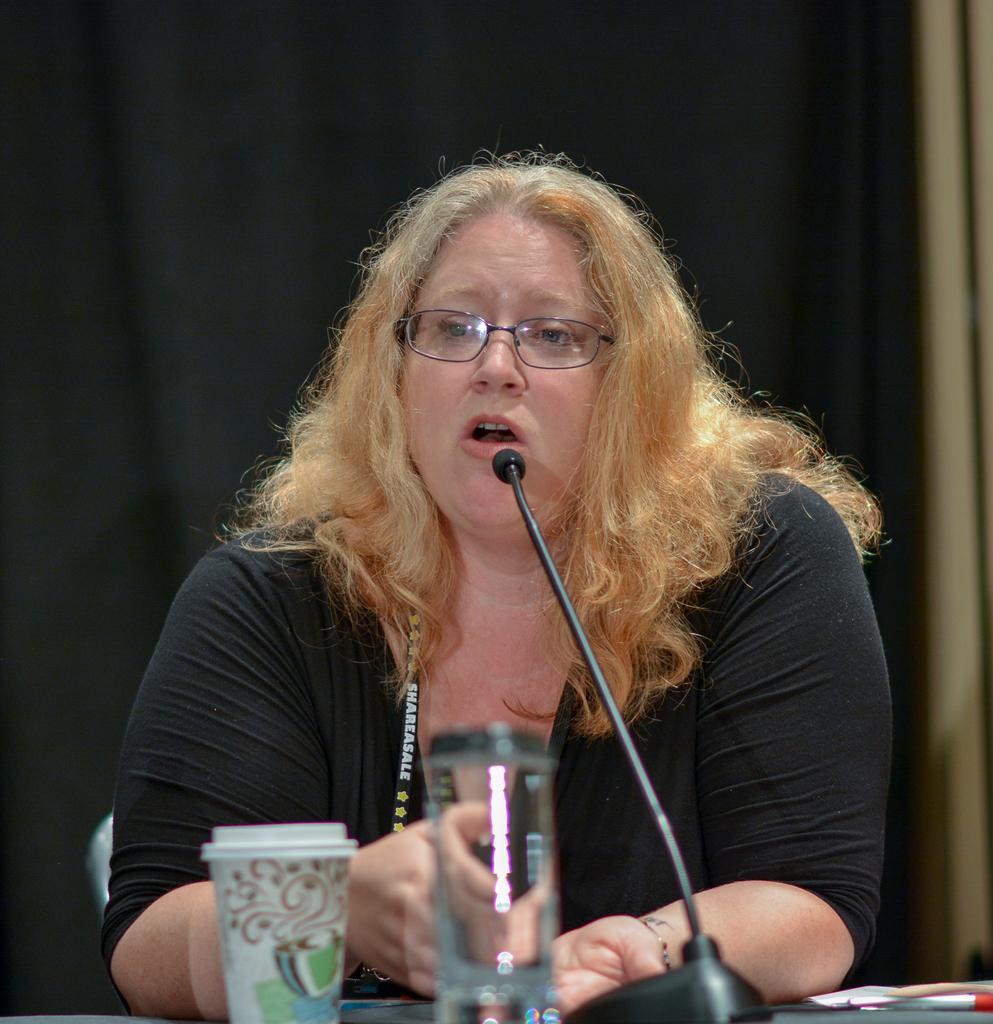In one or two sentences, can you explain what this image depicts? In the center of the image we can see woman sitting at the table. On the table we can see mic, glass tumbler, glass and pen. In the background we can see wall and curtain. 